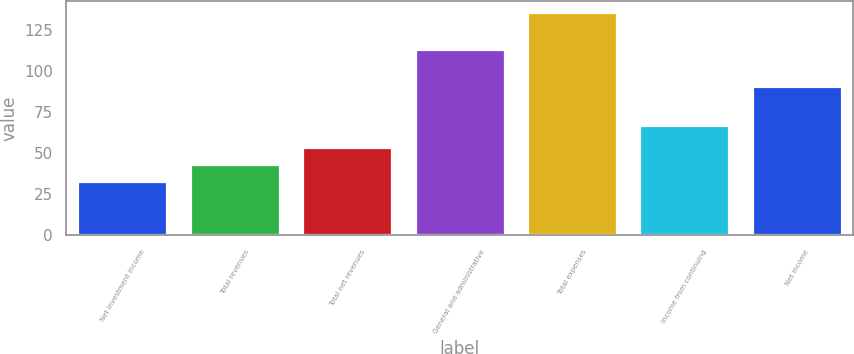Convert chart to OTSL. <chart><loc_0><loc_0><loc_500><loc_500><bar_chart><fcel>Net investment income<fcel>Total revenues<fcel>Total net revenues<fcel>General and administrative<fcel>Total expenses<fcel>Income from continuing<fcel>Net income<nl><fcel>33<fcel>43.3<fcel>53.6<fcel>113.3<fcel>136<fcel>67<fcel>91<nl></chart> 